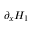<formula> <loc_0><loc_0><loc_500><loc_500>\partial _ { x } H _ { 1 }</formula> 